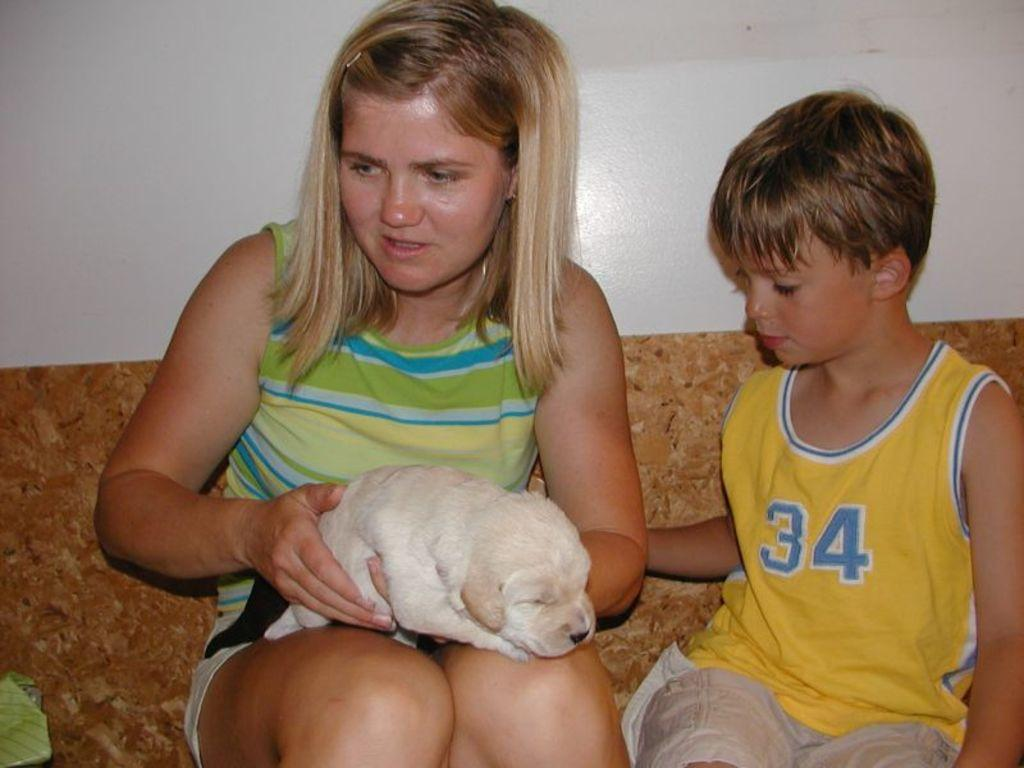What is the girl doing in the image? The girl is sitting on a sofa set. What is the girl holding in her hand? The girl is holding a baby dog in her hand. Who else is sitting on the sofa set? There is a boy sitting on the same sofa set. What type of tin can be seen hanging from the ceiling in the image? There is no tin present in the image; it features a girl sitting on a sofa set holding a baby dog and a boy sitting on the same sofa set. 